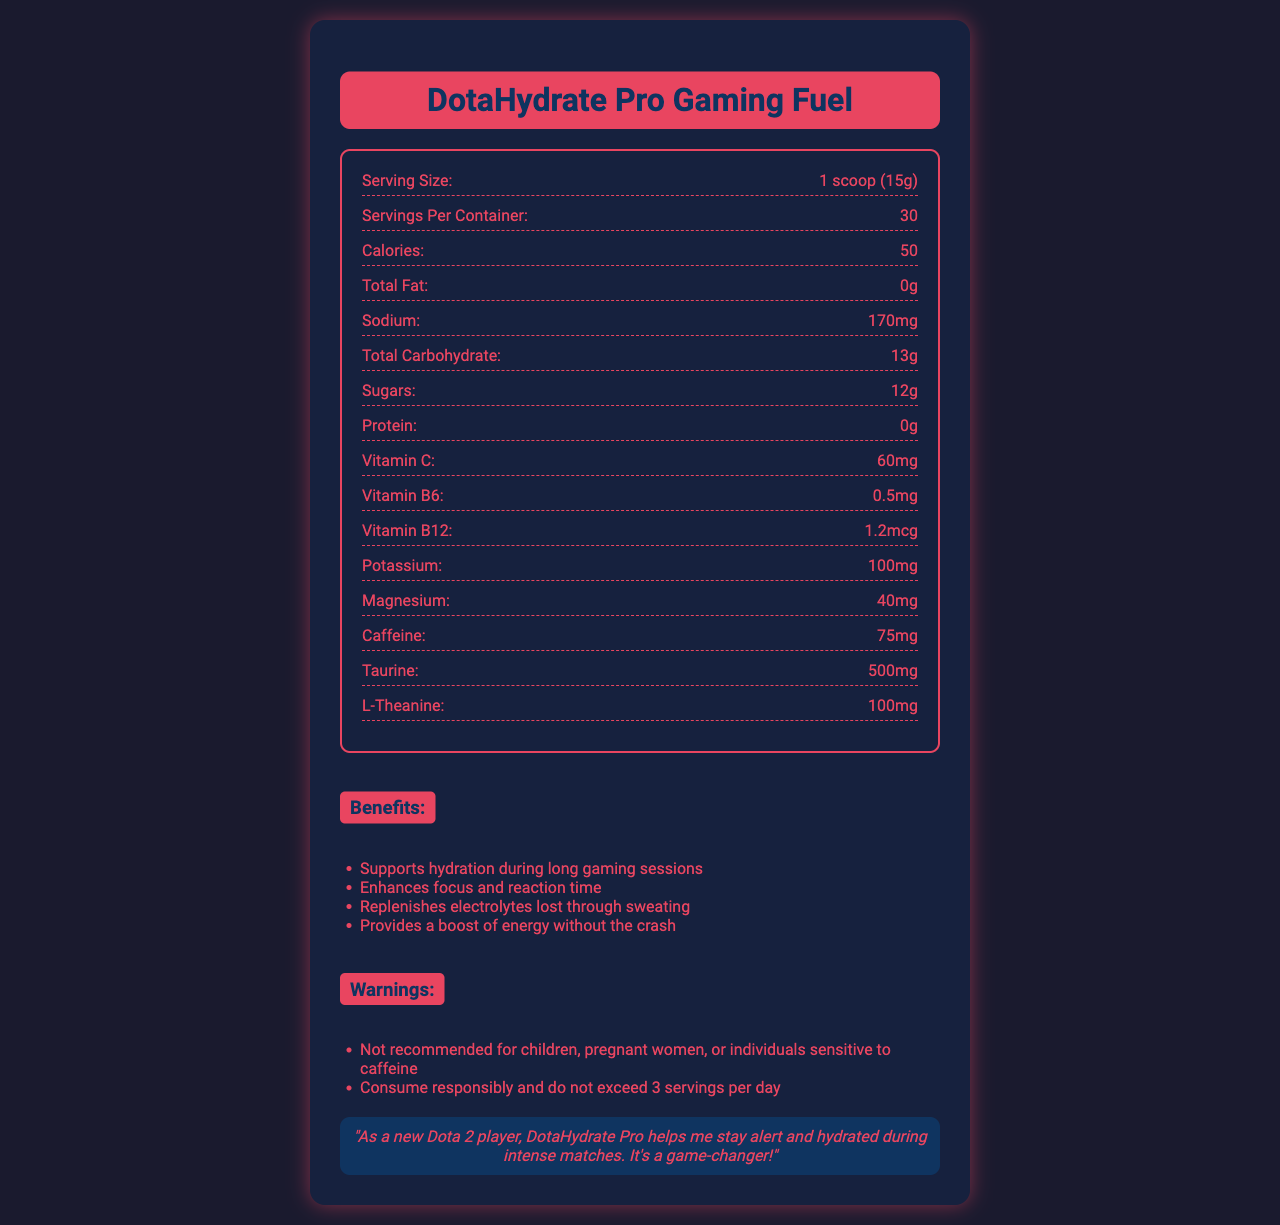what is the serving size? The document specifies that the serving size is 1 scoop, which equals 15 grams.
Answer: 1 scoop (15g) how many calories are in each serving? The document lists the calorie count as 50 per serving.
Answer: 50 calories what flavor is the DotaHydrate Pro Gaming Fuel? The flavor mentioned in the document is "Blue Radiance Blast".
Answer: Blue Radiance Blast what is the recommended amount of water to mix with one scoop? According to the directions, one scoop should be mixed with 16-20 oz of cold water.
Answer: 16-20 oz of cold water how much caffeine is in each serving? The nutrition facts indicate that there are 75 mg of caffeine per serving.
Answer: 75 mg how many servings are there per container? A. 20 B. 30 C. 25 The document states that there are 30 servings per container.
Answer: B. 30 which of the following ingredients is included in the electrolyte blend? A. Sodium Citrate B. Acesulfame Potassium C. Maltodextrin The electrolyte blend includes Sodium Citrate, but not Acesulfame Potassium or Maltodextrin.
Answer: A. Sodium Citrate is the product recommended for children? The warnings clearly state that it is not recommended for children.
Answer: No why is the product beneficial during long Dota 2 sessions? The benefits section outlines these four key advantages of the product during extended gaming sessions.
Answer: It supports hydration, enhances focus, replenishes electrolytes, and provides energy without the crash describe the main idea of the document The detailed explanation includes nutritional facts, benefits, flavor, directions, warnings, and a testimonial to give a comprehensive overview of the product.
Answer: The document provides detailed nutritional information about the DotaHydrate Pro Gaming Fuel, a hydration drink mix designed to support gamers during long Dota 2 matches. It outlines the serving size, calorie count, and various nutrients, including vitamins and electrolytes. Additionally, it highlights the product's flavor, directions for use, benefits, warnings, and a testimonial from a gamer. what is the specific amount of protein in each serving? The document indicates that there is no protein (0g) in each serving.
Answer: 0g how much taurine is included in one serving? The document states there are 500 mg of Taurine per serving.
Answer: 500 mg what is the daily limit for servings of this drink mix? The warning section advises not to exceed 3 servings per day.
Answer: 3 servings per day what's an ingredient used for sweetness in the product? One of the other ingredients listed is Sucralose, which is used for sweetness.
Answer: Sucralose how much vitamin B6 is in each serving? The document indicates that each serving contains 0.5 mg of Vitamin B6.
Answer: 0.5 mg what are the other benefits of this product not related to hydration? In addition to hydration, the product enhances focus and reaction time and provides energy without the crash.
Answer: Enhances focus and reaction time, provides a boost of energy without the crash how does the document suggest the product should be consumed? The directions specify to mix 1 scoop with 16-20 oz of cold water and consume it during extended gaming sessions.
Answer: Mix 1 scoop with 16-20 oz of cold water, and consume during extended Dota 2 sessions how much potassium is in the electrolyte blend? The document lists only the individual amounts of each nutrient but does not specify the amount within the electrolyte blend.
Answer: Cannot be determined does the product contain any fat? The document shows the total fat content as 0g, indicating there is no fat in the product.
Answer: No 